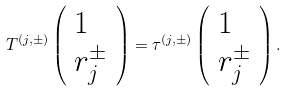Convert formula to latex. <formula><loc_0><loc_0><loc_500><loc_500>T ^ { ( j , \pm ) } \left ( \begin{array} { l } 1 \\ r _ { j } ^ { \pm } \end{array} \right ) = \tau ^ { ( j , \pm ) } \left ( \begin{array} { l } 1 \\ r _ { j } ^ { \pm } \end{array} \right ) .</formula> 